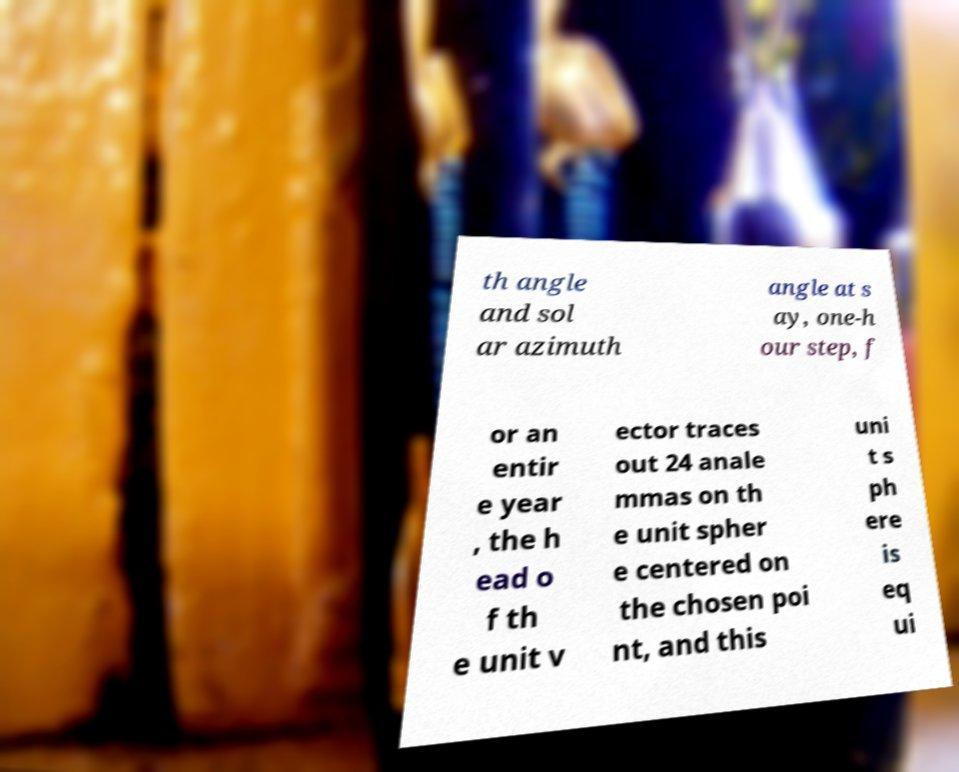Could you extract and type out the text from this image? th angle and sol ar azimuth angle at s ay, one-h our step, f or an entir e year , the h ead o f th e unit v ector traces out 24 anale mmas on th e unit spher e centered on the chosen poi nt, and this uni t s ph ere is eq ui 